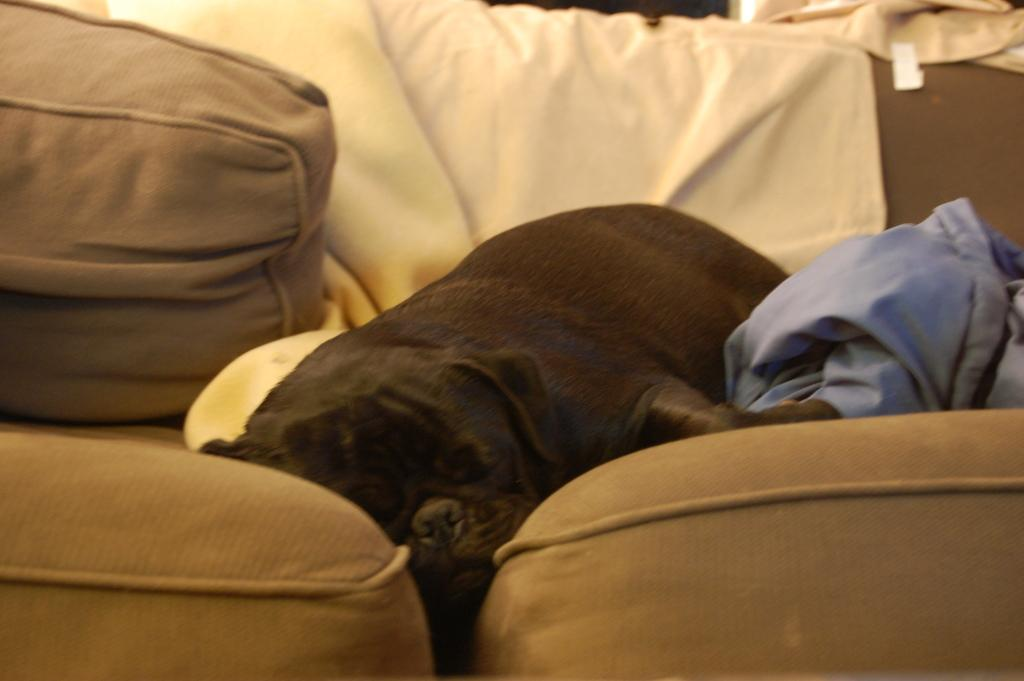What type of furniture is present in the image? There is a sofa in the image. What other living beings can be seen in the image? There are animals in the image. Can you describe any other objects in the image? There are some objects in the image. What type of reward is being given to the ducks in the image? There are no ducks present in the image, so there is no reward being given to them. What tool is being used to fix the wrench in the image? There is no wrench present in the image, so no tool is being used to fix it. 